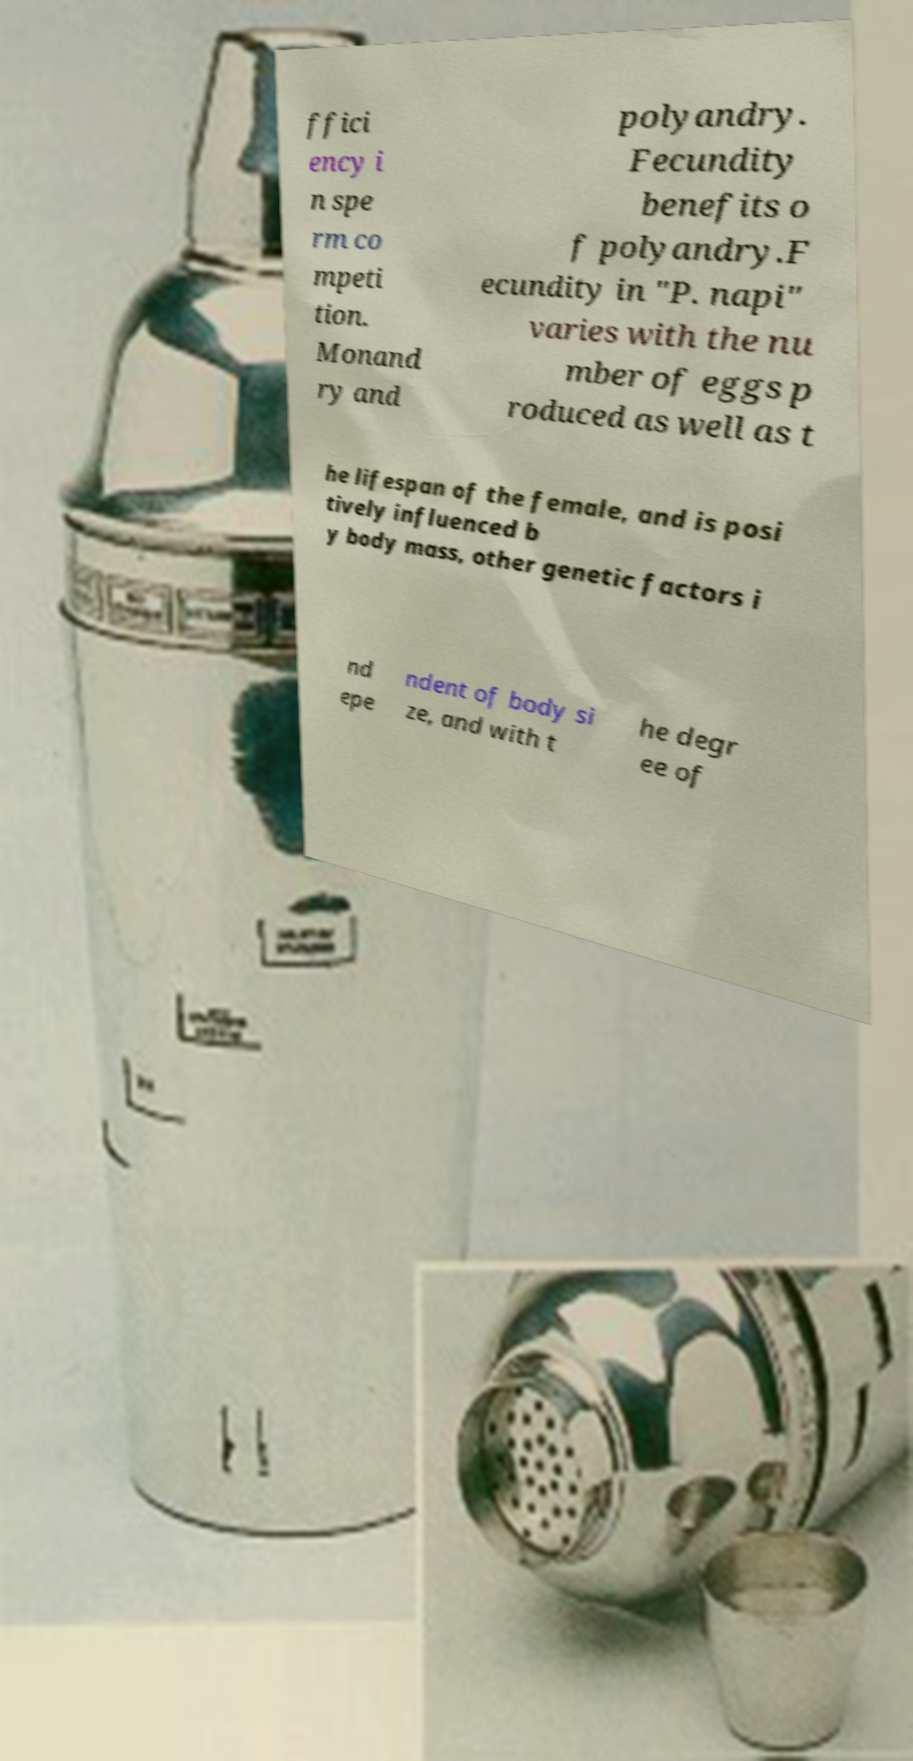There's text embedded in this image that I need extracted. Can you transcribe it verbatim? ffici ency i n spe rm co mpeti tion. Monand ry and polyandry. Fecundity benefits o f polyandry.F ecundity in "P. napi" varies with the nu mber of eggs p roduced as well as t he lifespan of the female, and is posi tively influenced b y body mass, other genetic factors i nd epe ndent of body si ze, and with t he degr ee of 